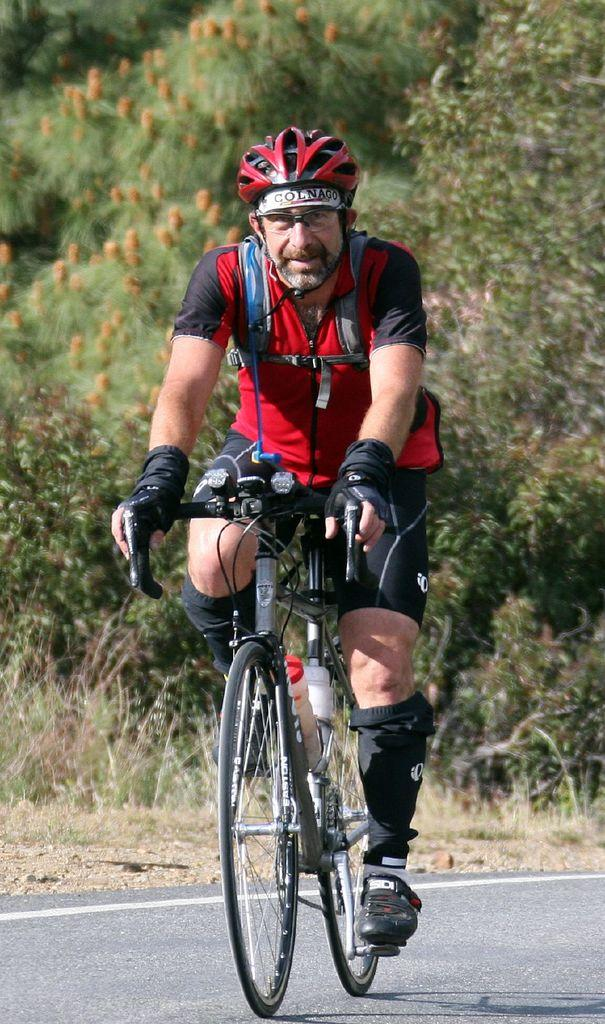Who is the main subject in the image? There is a man in the image. What is the man doing in the image? The man is riding a bicycle. What can be seen in the background of the image? There are trees visible in the background of the image. Is there a volcano erupting in the background of the image? No, there is no volcano present in the image. What type of cast is visible on the man's arm while he is riding the bicycle? There is no cast visible on the man's arm in the image. 